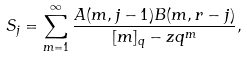Convert formula to latex. <formula><loc_0><loc_0><loc_500><loc_500>S _ { j } = \sum _ { m = 1 } ^ { \infty } \frac { A ( m , j - 1 ) B ( m , r - j ) } { [ m ] _ { q } - z q ^ { m } } ,</formula> 